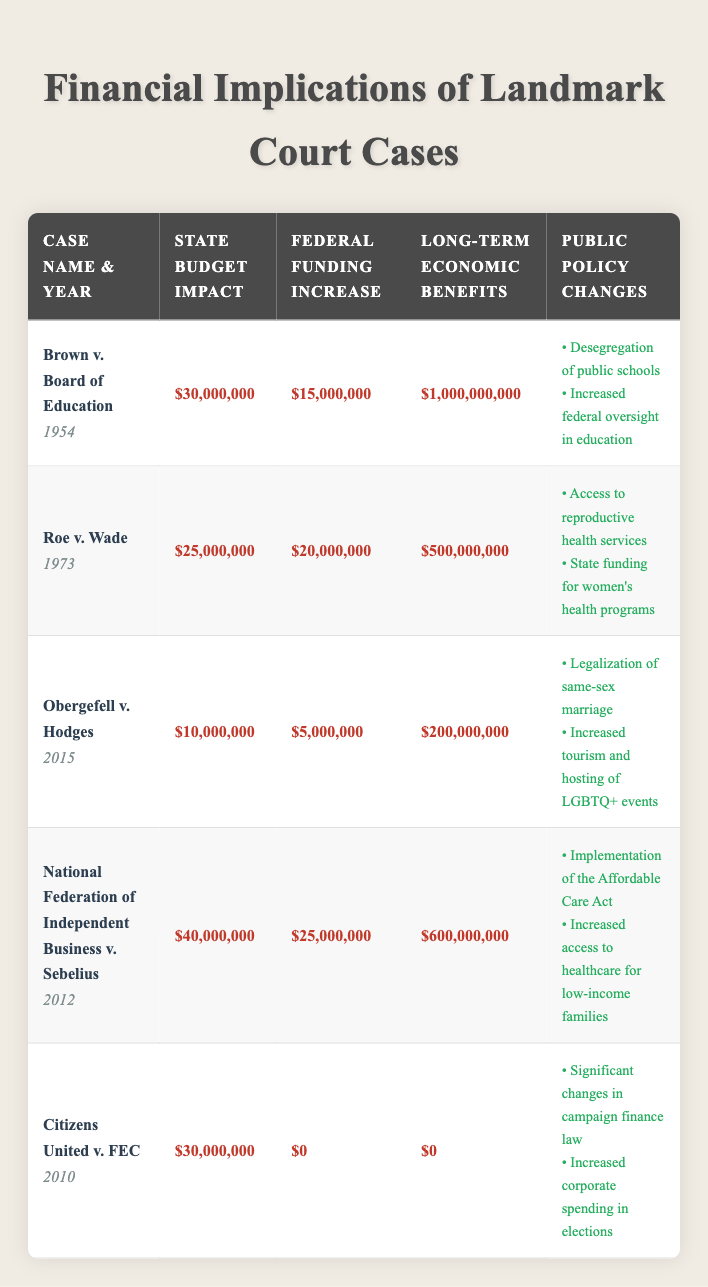What is the estimated state budget impact of Roe v. Wade? The table indicates that the estimated state budget impact of Roe v. Wade is listed under the "State Budget Impact" column as $25,000,000.
Answer: $25,000,000 Which landmark case had the highest long-term economic benefits? By reviewing the "Long-term Economic Benefits" column, Brown v. Board of Education has the highest value at $1,000,000,000 compared to others.
Answer: Brown v. Board of Education What is the total federal funding increase for all cases listed in the table? To find the total federal funding increase, sum the values in the "Federal Funding Increase" column: 15,000,000 + 20,000,000 + 5,000,000 + 25,000,000 + 0 = 65,000,000.
Answer: $65,000,000 Did Citizens United v. FEC lead to any long-term economic benefits? According to the table, Citizens United v. FEC has a long-term economic benefits entry of $0, which indicates there were no benefits.
Answer: No What is the difference between the estimated state budget impact of National Federation of Independent Business v. Sebelius and Obergefell v. Hodges? The estimated state budget impacts are $40,000,000 for National Federation of Independent Business v. Sebelius and $10,000,000 for Obergefell v. Hodges. The difference is $40,000,000 - $10,000,000 = $30,000,000.
Answer: $30,000,000 Which cases resulted in public policy changes related to healthcare? By checking the "Public Policy Changes" column, National Federation of Independent Business v. Sebelius mentions the implementation of the Affordable Care Act and increased access to healthcare for low-income families.
Answer: National Federation of Independent Business v. Sebelius What is the average estimated state budget impact across all cases? To find the average, sum the state budget impacts: 30,000,000 + 25,000,000 + 10,000,000 + 40,000,000 + 30,000,000 = 135,000,000. Then, divide by the number of cases (5): 135,000,000 / 5 = 27,000,000.
Answer: $27,000,000 Is it true that Obergefell v. Hodges resulted in increased federal funding? The table states that the federal funding increase for Obergefell v. Hodges is $5,000,000, which confirms that there was an increase.
Answer: Yes How much total state budget impact is represented by the cases that mention society-related policy changes? The cases with societal impacts are Brown v. Board of Education ($30,000,000) and Obergefell v. Hodges ($10,000,000). Adding these gives $30,000,000 + $10,000,000 = $40,000,000.
Answer: $40,000,000 